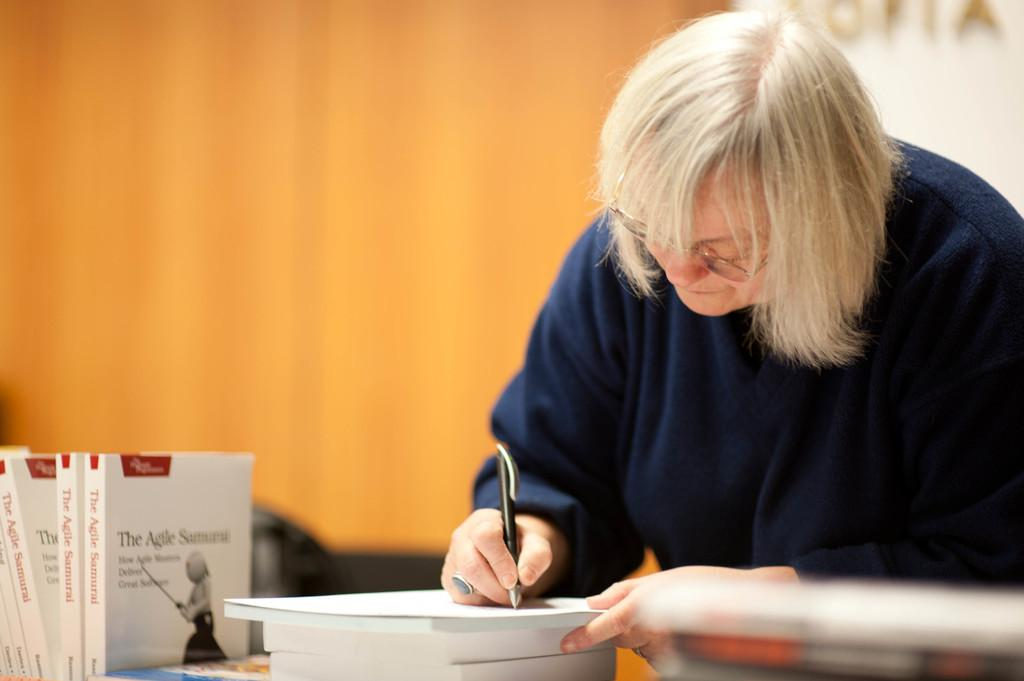<image>
Relay a brief, clear account of the picture shown. A person writes on a sheet of paper next to a copy of The Agile Samurai. 